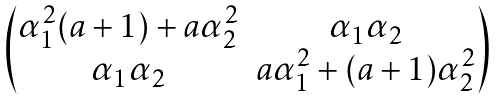Convert formula to latex. <formula><loc_0><loc_0><loc_500><loc_500>\begin{array} { l l } \begin{pmatrix} \alpha _ { 1 } ^ { 2 } ( a + 1 ) + a \alpha _ { 2 } ^ { 2 } & \alpha _ { 1 } \alpha _ { 2 } \\ \alpha _ { 1 } \alpha _ { 2 } & a \alpha _ { 1 } ^ { 2 } + ( a + 1 ) \alpha _ { 2 } ^ { 2 } \end{pmatrix} \end{array}</formula> 